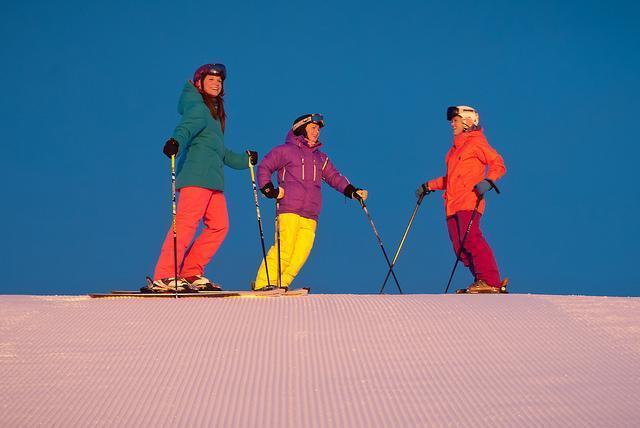How many people are there?
Give a very brief answer. 3. 